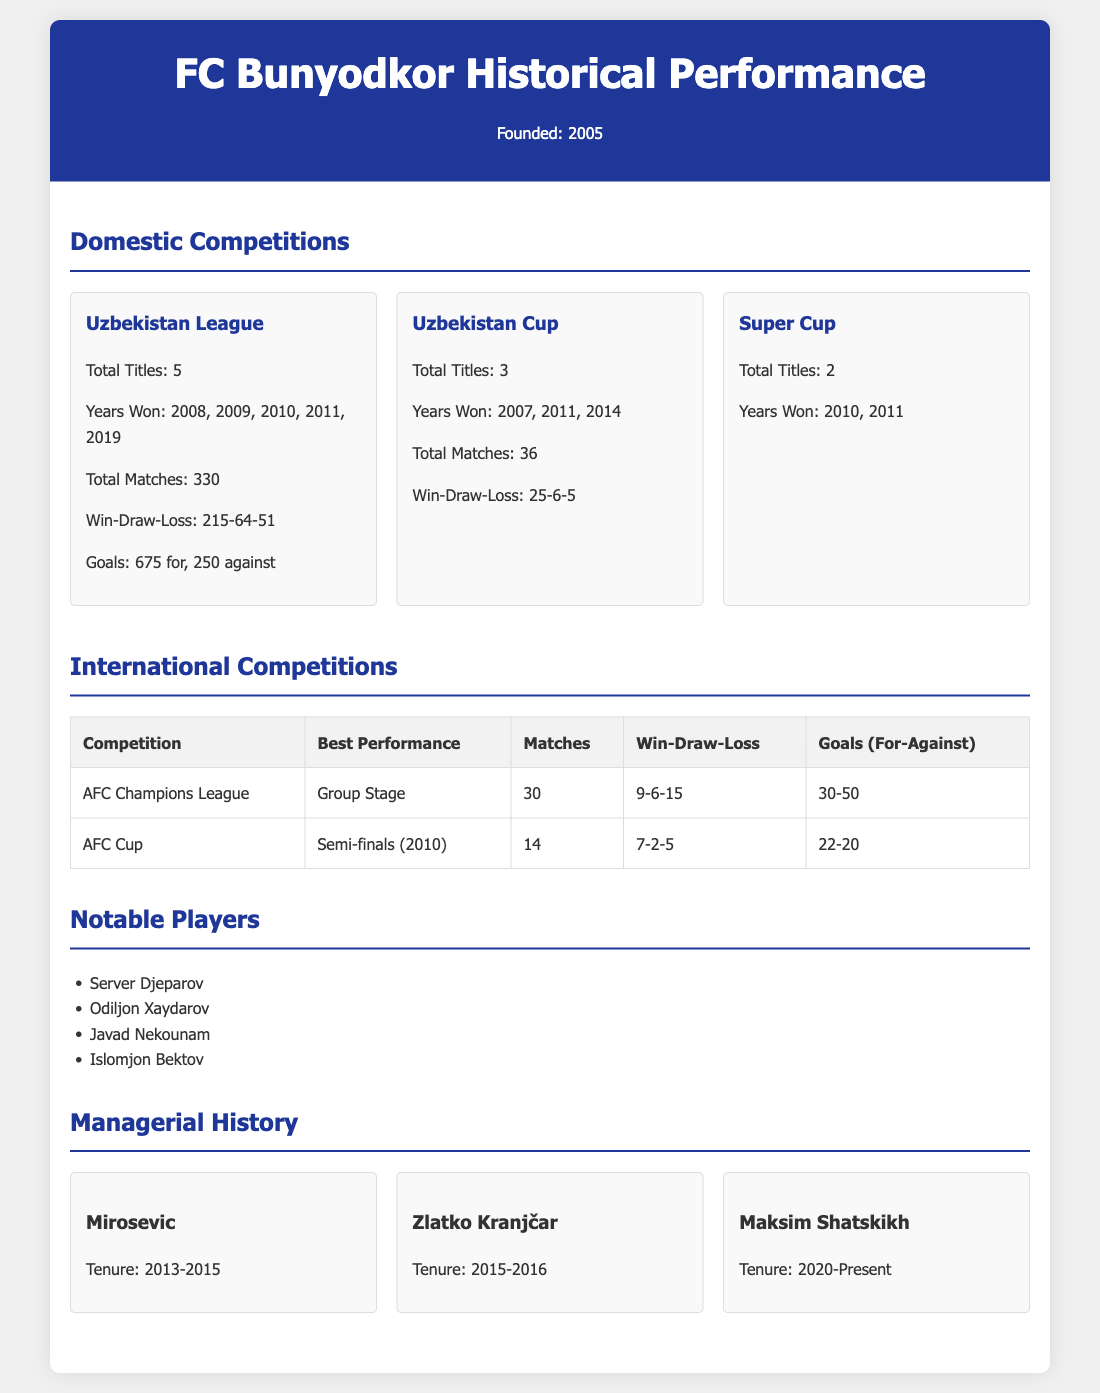What is the total number of titles FC Bunyodkor has won in the Uzbekistan League? The total number of titles is listed under the Uzbekistan League section, which states "Total Titles: 5".
Answer: 5 In what year did FC Bunyodkor win the Uzbekistan Cup for the last time? The years won are listed under the Uzbekistan Cup section, where the last mentioned year is "2014".
Answer: 2014 How many matches has FC Bunyodkor played in the AFC Champions League? The number of matches is indicated in the international competitions section specifically for AFC Champions League, which states "Matches: 30".
Answer: 30 Who managed FC Bunyodkor from 2015 to 2016? The managerial history provides names and tenures, and it lists "Zlatko Kranjčar" for that period.
Answer: Zlatko Kranjčar What was FC Bunyodkor's best performance in the AFC Cup? The best performance is detailed in the AFC Cup section as "Semi-finals (2010)".
Answer: Semi-finals (2010) How many goals did FC Bunyodkor score against their opponents in the Uzbekistan League? The goals scored for and against are specified, with goals "675 for".
Answer: 675 What is the win-loss record for FC Bunyodkor in the Uzbekistan Cup? The win-loss record is presented in the Uzbekistan Cup section as "25-6-5".
Answer: 25-6-5 Which notable player has the name "Server Djeparov"? This name is listed as part of the notable players section, indicating a significant figure for the club.
Answer: Server Djeparov How many total matches did FC Bunyodkor play in domestic competitions? The total matches across domestic competitions are summarized with "330" for the Uzbekistan League and "36" for the Uzbekistan Cup.
Answer: 366 (combined total) 